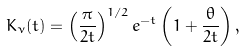<formula> <loc_0><loc_0><loc_500><loc_500>K _ { \nu } ( t ) = \left ( \frac { \pi } { 2 t } \right ) ^ { 1 / 2 } e ^ { - t } \left ( 1 + \frac { \theta } { 2 t } \right ) ,</formula> 